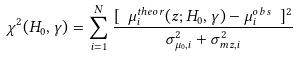<formula> <loc_0><loc_0><loc_500><loc_500>\chi ^ { 2 } ( H _ { 0 } , \gamma ) = \sum _ { i = 1 } ^ { N } { \frac { [ \ \mu _ { i } ^ { t h e o r } ( z ; H _ { 0 } , \gamma ) - \mu _ { i } ^ { o b s } \ ] ^ { 2 } } { \sigma ^ { 2 } _ { \mu _ { 0 } , i } + \sigma ^ { 2 } _ { m z , i } } }</formula> 